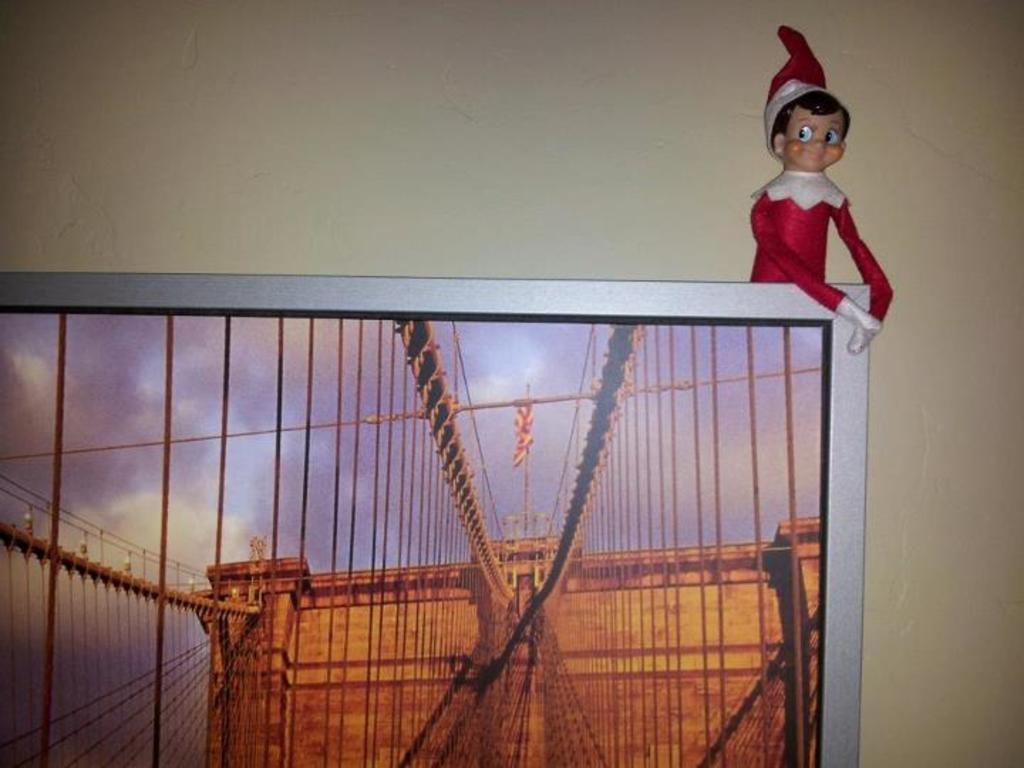What is the main object in the image? There is a screen in the image. What can be seen on the screen? The screen displays a view of buildings, ropes, and the sky. What is behind the screen? There is a wall behind the screen. What is in front of the wall? A doll is visible in front of the wall. What type of boot can be seen in the afternoon in the image? There is no boot or reference to a specific time of day in the image; it features a screen displaying a view of buildings, ropes, and the sky, with a wall and a doll in front of it. 